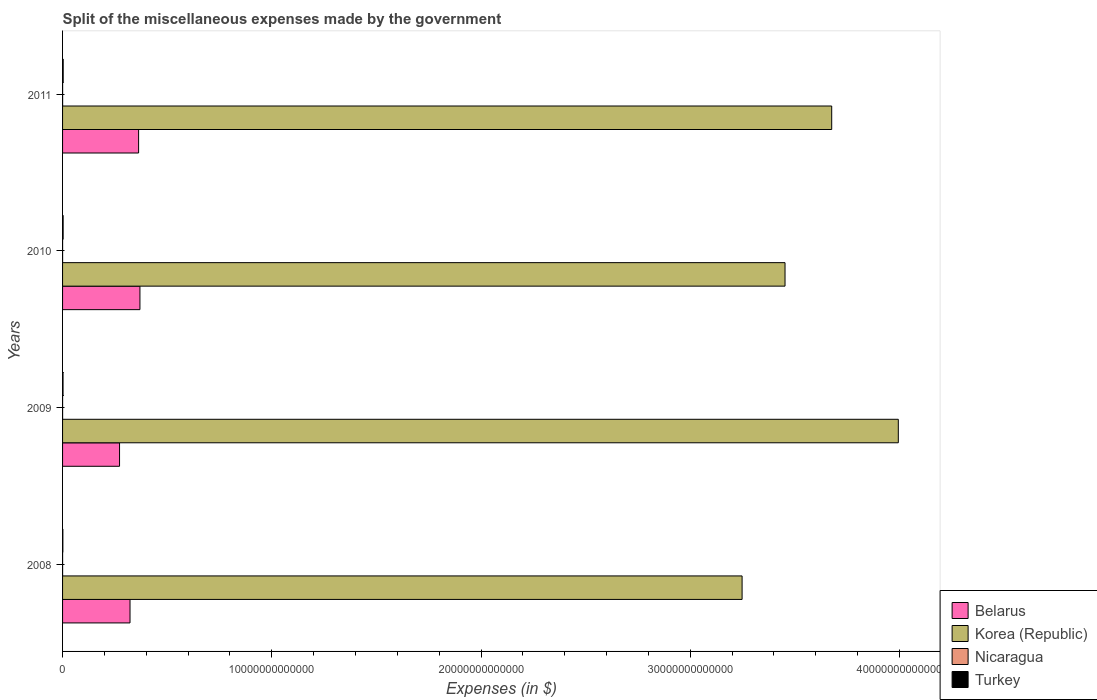How many different coloured bars are there?
Keep it short and to the point. 4. How many groups of bars are there?
Offer a terse response. 4. Are the number of bars per tick equal to the number of legend labels?
Offer a terse response. Yes. How many bars are there on the 2nd tick from the top?
Provide a succinct answer. 4. How many bars are there on the 2nd tick from the bottom?
Give a very brief answer. 4. What is the label of the 3rd group of bars from the top?
Offer a very short reply. 2009. What is the miscellaneous expenses made by the government in Belarus in 2008?
Provide a succinct answer. 3.22e+12. Across all years, what is the maximum miscellaneous expenses made by the government in Korea (Republic)?
Keep it short and to the point. 3.99e+13. Across all years, what is the minimum miscellaneous expenses made by the government in Turkey?
Keep it short and to the point. 1.38e+1. What is the total miscellaneous expenses made by the government in Nicaragua in the graph?
Your answer should be compact. 6.28e+09. What is the difference between the miscellaneous expenses made by the government in Belarus in 2009 and that in 2010?
Ensure brevity in your answer.  -9.74e+11. What is the difference between the miscellaneous expenses made by the government in Turkey in 2009 and the miscellaneous expenses made by the government in Belarus in 2011?
Give a very brief answer. -3.61e+12. What is the average miscellaneous expenses made by the government in Korea (Republic) per year?
Provide a short and direct response. 3.59e+13. In the year 2010, what is the difference between the miscellaneous expenses made by the government in Korea (Republic) and miscellaneous expenses made by the government in Belarus?
Offer a very short reply. 3.08e+13. In how many years, is the miscellaneous expenses made by the government in Turkey greater than 30000000000000 $?
Give a very brief answer. 0. What is the ratio of the miscellaneous expenses made by the government in Korea (Republic) in 2009 to that in 2010?
Ensure brevity in your answer.  1.16. Is the miscellaneous expenses made by the government in Turkey in 2010 less than that in 2011?
Offer a terse response. Yes. Is the difference between the miscellaneous expenses made by the government in Korea (Republic) in 2010 and 2011 greater than the difference between the miscellaneous expenses made by the government in Belarus in 2010 and 2011?
Your response must be concise. No. What is the difference between the highest and the second highest miscellaneous expenses made by the government in Nicaragua?
Make the answer very short. 1.44e+08. What is the difference between the highest and the lowest miscellaneous expenses made by the government in Nicaragua?
Give a very brief answer. 3.96e+08. Is the sum of the miscellaneous expenses made by the government in Turkey in 2008 and 2010 greater than the maximum miscellaneous expenses made by the government in Korea (Republic) across all years?
Your answer should be compact. No. Is it the case that in every year, the sum of the miscellaneous expenses made by the government in Nicaragua and miscellaneous expenses made by the government in Belarus is greater than the sum of miscellaneous expenses made by the government in Turkey and miscellaneous expenses made by the government in Korea (Republic)?
Offer a terse response. No. What does the 2nd bar from the top in 2008 represents?
Your answer should be very brief. Nicaragua. What does the 2nd bar from the bottom in 2009 represents?
Make the answer very short. Korea (Republic). What is the difference between two consecutive major ticks on the X-axis?
Ensure brevity in your answer.  1.00e+13. Does the graph contain any zero values?
Ensure brevity in your answer.  No. How are the legend labels stacked?
Your response must be concise. Vertical. What is the title of the graph?
Offer a terse response. Split of the miscellaneous expenses made by the government. Does "Cyprus" appear as one of the legend labels in the graph?
Keep it short and to the point. No. What is the label or title of the X-axis?
Provide a succinct answer. Expenses (in $). What is the Expenses (in $) in Belarus in 2008?
Make the answer very short. 3.22e+12. What is the Expenses (in $) in Korea (Republic) in 2008?
Offer a terse response. 3.25e+13. What is the Expenses (in $) of Nicaragua in 2008?
Your response must be concise. 1.65e+09. What is the Expenses (in $) of Turkey in 2008?
Your response must be concise. 1.38e+1. What is the Expenses (in $) in Belarus in 2009?
Keep it short and to the point. 2.72e+12. What is the Expenses (in $) in Korea (Republic) in 2009?
Offer a terse response. 3.99e+13. What is the Expenses (in $) in Nicaragua in 2009?
Give a very brief answer. 1.42e+09. What is the Expenses (in $) of Turkey in 2009?
Keep it short and to the point. 2.21e+1. What is the Expenses (in $) of Belarus in 2010?
Offer a very short reply. 3.70e+12. What is the Expenses (in $) in Korea (Republic) in 2010?
Offer a terse response. 3.45e+13. What is the Expenses (in $) in Nicaragua in 2010?
Your response must be concise. 1.40e+09. What is the Expenses (in $) in Turkey in 2010?
Provide a succinct answer. 2.64e+1. What is the Expenses (in $) in Belarus in 2011?
Your answer should be very brief. 3.63e+12. What is the Expenses (in $) in Korea (Republic) in 2011?
Your answer should be compact. 3.68e+13. What is the Expenses (in $) of Nicaragua in 2011?
Offer a very short reply. 1.80e+09. What is the Expenses (in $) in Turkey in 2011?
Your answer should be compact. 2.91e+1. Across all years, what is the maximum Expenses (in $) in Belarus?
Provide a succinct answer. 3.70e+12. Across all years, what is the maximum Expenses (in $) in Korea (Republic)?
Provide a short and direct response. 3.99e+13. Across all years, what is the maximum Expenses (in $) of Nicaragua?
Give a very brief answer. 1.80e+09. Across all years, what is the maximum Expenses (in $) of Turkey?
Give a very brief answer. 2.91e+1. Across all years, what is the minimum Expenses (in $) of Belarus?
Make the answer very short. 2.72e+12. Across all years, what is the minimum Expenses (in $) in Korea (Republic)?
Your answer should be compact. 3.25e+13. Across all years, what is the minimum Expenses (in $) of Nicaragua?
Offer a very short reply. 1.40e+09. Across all years, what is the minimum Expenses (in $) in Turkey?
Ensure brevity in your answer.  1.38e+1. What is the total Expenses (in $) in Belarus in the graph?
Ensure brevity in your answer.  1.33e+13. What is the total Expenses (in $) of Korea (Republic) in the graph?
Keep it short and to the point. 1.44e+14. What is the total Expenses (in $) in Nicaragua in the graph?
Provide a succinct answer. 6.28e+09. What is the total Expenses (in $) of Turkey in the graph?
Your response must be concise. 9.14e+1. What is the difference between the Expenses (in $) of Belarus in 2008 and that in 2009?
Your answer should be compact. 5.00e+11. What is the difference between the Expenses (in $) of Korea (Republic) in 2008 and that in 2009?
Offer a terse response. -7.47e+12. What is the difference between the Expenses (in $) in Nicaragua in 2008 and that in 2009?
Provide a short and direct response. 2.35e+08. What is the difference between the Expenses (in $) in Turkey in 2008 and that in 2009?
Offer a very short reply. -8.25e+09. What is the difference between the Expenses (in $) in Belarus in 2008 and that in 2010?
Your answer should be compact. -4.74e+11. What is the difference between the Expenses (in $) of Korea (Republic) in 2008 and that in 2010?
Provide a succinct answer. -2.05e+12. What is the difference between the Expenses (in $) of Nicaragua in 2008 and that in 2010?
Ensure brevity in your answer.  2.52e+08. What is the difference between the Expenses (in $) of Turkey in 2008 and that in 2010?
Offer a very short reply. -1.26e+1. What is the difference between the Expenses (in $) of Belarus in 2008 and that in 2011?
Your answer should be compact. -4.11e+11. What is the difference between the Expenses (in $) of Korea (Republic) in 2008 and that in 2011?
Your response must be concise. -4.28e+12. What is the difference between the Expenses (in $) of Nicaragua in 2008 and that in 2011?
Your answer should be very brief. -1.44e+08. What is the difference between the Expenses (in $) of Turkey in 2008 and that in 2011?
Your answer should be very brief. -1.53e+1. What is the difference between the Expenses (in $) in Belarus in 2009 and that in 2010?
Make the answer very short. -9.74e+11. What is the difference between the Expenses (in $) in Korea (Republic) in 2009 and that in 2010?
Your response must be concise. 5.41e+12. What is the difference between the Expenses (in $) of Nicaragua in 2009 and that in 2010?
Provide a succinct answer. 1.63e+07. What is the difference between the Expenses (in $) of Turkey in 2009 and that in 2010?
Offer a very short reply. -4.34e+09. What is the difference between the Expenses (in $) of Belarus in 2009 and that in 2011?
Your answer should be very brief. -9.11e+11. What is the difference between the Expenses (in $) in Korea (Republic) in 2009 and that in 2011?
Your answer should be very brief. 3.18e+12. What is the difference between the Expenses (in $) in Nicaragua in 2009 and that in 2011?
Offer a very short reply. -3.80e+08. What is the difference between the Expenses (in $) in Turkey in 2009 and that in 2011?
Keep it short and to the point. -7.08e+09. What is the difference between the Expenses (in $) of Belarus in 2010 and that in 2011?
Keep it short and to the point. 6.31e+1. What is the difference between the Expenses (in $) in Korea (Republic) in 2010 and that in 2011?
Offer a very short reply. -2.23e+12. What is the difference between the Expenses (in $) in Nicaragua in 2010 and that in 2011?
Offer a terse response. -3.96e+08. What is the difference between the Expenses (in $) of Turkey in 2010 and that in 2011?
Give a very brief answer. -2.75e+09. What is the difference between the Expenses (in $) of Belarus in 2008 and the Expenses (in $) of Korea (Republic) in 2009?
Provide a succinct answer. -3.67e+13. What is the difference between the Expenses (in $) of Belarus in 2008 and the Expenses (in $) of Nicaragua in 2009?
Offer a very short reply. 3.22e+12. What is the difference between the Expenses (in $) in Belarus in 2008 and the Expenses (in $) in Turkey in 2009?
Offer a very short reply. 3.20e+12. What is the difference between the Expenses (in $) of Korea (Republic) in 2008 and the Expenses (in $) of Nicaragua in 2009?
Provide a succinct answer. 3.25e+13. What is the difference between the Expenses (in $) in Korea (Republic) in 2008 and the Expenses (in $) in Turkey in 2009?
Your answer should be very brief. 3.25e+13. What is the difference between the Expenses (in $) in Nicaragua in 2008 and the Expenses (in $) in Turkey in 2009?
Your answer should be very brief. -2.04e+1. What is the difference between the Expenses (in $) of Belarus in 2008 and the Expenses (in $) of Korea (Republic) in 2010?
Ensure brevity in your answer.  -3.13e+13. What is the difference between the Expenses (in $) in Belarus in 2008 and the Expenses (in $) in Nicaragua in 2010?
Provide a short and direct response. 3.22e+12. What is the difference between the Expenses (in $) in Belarus in 2008 and the Expenses (in $) in Turkey in 2010?
Your answer should be very brief. 3.20e+12. What is the difference between the Expenses (in $) of Korea (Republic) in 2008 and the Expenses (in $) of Nicaragua in 2010?
Your answer should be very brief. 3.25e+13. What is the difference between the Expenses (in $) in Korea (Republic) in 2008 and the Expenses (in $) in Turkey in 2010?
Provide a short and direct response. 3.25e+13. What is the difference between the Expenses (in $) in Nicaragua in 2008 and the Expenses (in $) in Turkey in 2010?
Offer a terse response. -2.47e+1. What is the difference between the Expenses (in $) in Belarus in 2008 and the Expenses (in $) in Korea (Republic) in 2011?
Keep it short and to the point. -3.35e+13. What is the difference between the Expenses (in $) of Belarus in 2008 and the Expenses (in $) of Nicaragua in 2011?
Ensure brevity in your answer.  3.22e+12. What is the difference between the Expenses (in $) of Belarus in 2008 and the Expenses (in $) of Turkey in 2011?
Offer a terse response. 3.19e+12. What is the difference between the Expenses (in $) in Korea (Republic) in 2008 and the Expenses (in $) in Nicaragua in 2011?
Provide a short and direct response. 3.25e+13. What is the difference between the Expenses (in $) of Korea (Republic) in 2008 and the Expenses (in $) of Turkey in 2011?
Make the answer very short. 3.25e+13. What is the difference between the Expenses (in $) in Nicaragua in 2008 and the Expenses (in $) in Turkey in 2011?
Ensure brevity in your answer.  -2.75e+1. What is the difference between the Expenses (in $) of Belarus in 2009 and the Expenses (in $) of Korea (Republic) in 2010?
Keep it short and to the point. -3.18e+13. What is the difference between the Expenses (in $) of Belarus in 2009 and the Expenses (in $) of Nicaragua in 2010?
Provide a short and direct response. 2.72e+12. What is the difference between the Expenses (in $) in Belarus in 2009 and the Expenses (in $) in Turkey in 2010?
Make the answer very short. 2.70e+12. What is the difference between the Expenses (in $) of Korea (Republic) in 2009 and the Expenses (in $) of Nicaragua in 2010?
Make the answer very short. 3.99e+13. What is the difference between the Expenses (in $) in Korea (Republic) in 2009 and the Expenses (in $) in Turkey in 2010?
Provide a short and direct response. 3.99e+13. What is the difference between the Expenses (in $) in Nicaragua in 2009 and the Expenses (in $) in Turkey in 2010?
Offer a terse response. -2.50e+1. What is the difference between the Expenses (in $) of Belarus in 2009 and the Expenses (in $) of Korea (Republic) in 2011?
Keep it short and to the point. -3.40e+13. What is the difference between the Expenses (in $) of Belarus in 2009 and the Expenses (in $) of Nicaragua in 2011?
Your answer should be compact. 2.72e+12. What is the difference between the Expenses (in $) in Belarus in 2009 and the Expenses (in $) in Turkey in 2011?
Keep it short and to the point. 2.69e+12. What is the difference between the Expenses (in $) in Korea (Republic) in 2009 and the Expenses (in $) in Nicaragua in 2011?
Your answer should be compact. 3.99e+13. What is the difference between the Expenses (in $) in Korea (Republic) in 2009 and the Expenses (in $) in Turkey in 2011?
Ensure brevity in your answer.  3.99e+13. What is the difference between the Expenses (in $) of Nicaragua in 2009 and the Expenses (in $) of Turkey in 2011?
Ensure brevity in your answer.  -2.77e+1. What is the difference between the Expenses (in $) of Belarus in 2010 and the Expenses (in $) of Korea (Republic) in 2011?
Provide a succinct answer. -3.31e+13. What is the difference between the Expenses (in $) of Belarus in 2010 and the Expenses (in $) of Nicaragua in 2011?
Keep it short and to the point. 3.70e+12. What is the difference between the Expenses (in $) of Belarus in 2010 and the Expenses (in $) of Turkey in 2011?
Offer a terse response. 3.67e+12. What is the difference between the Expenses (in $) of Korea (Republic) in 2010 and the Expenses (in $) of Nicaragua in 2011?
Offer a terse response. 3.45e+13. What is the difference between the Expenses (in $) of Korea (Republic) in 2010 and the Expenses (in $) of Turkey in 2011?
Offer a very short reply. 3.45e+13. What is the difference between the Expenses (in $) in Nicaragua in 2010 and the Expenses (in $) in Turkey in 2011?
Provide a short and direct response. -2.77e+1. What is the average Expenses (in $) in Belarus per year?
Your answer should be very brief. 3.32e+12. What is the average Expenses (in $) in Korea (Republic) per year?
Your response must be concise. 3.59e+13. What is the average Expenses (in $) in Nicaragua per year?
Your answer should be compact. 1.57e+09. What is the average Expenses (in $) in Turkey per year?
Offer a terse response. 2.29e+1. In the year 2008, what is the difference between the Expenses (in $) in Belarus and Expenses (in $) in Korea (Republic)?
Make the answer very short. -2.93e+13. In the year 2008, what is the difference between the Expenses (in $) of Belarus and Expenses (in $) of Nicaragua?
Give a very brief answer. 3.22e+12. In the year 2008, what is the difference between the Expenses (in $) in Belarus and Expenses (in $) in Turkey?
Give a very brief answer. 3.21e+12. In the year 2008, what is the difference between the Expenses (in $) of Korea (Republic) and Expenses (in $) of Nicaragua?
Provide a succinct answer. 3.25e+13. In the year 2008, what is the difference between the Expenses (in $) in Korea (Republic) and Expenses (in $) in Turkey?
Your answer should be very brief. 3.25e+13. In the year 2008, what is the difference between the Expenses (in $) in Nicaragua and Expenses (in $) in Turkey?
Provide a succinct answer. -1.22e+1. In the year 2009, what is the difference between the Expenses (in $) of Belarus and Expenses (in $) of Korea (Republic)?
Give a very brief answer. -3.72e+13. In the year 2009, what is the difference between the Expenses (in $) of Belarus and Expenses (in $) of Nicaragua?
Make the answer very short. 2.72e+12. In the year 2009, what is the difference between the Expenses (in $) of Belarus and Expenses (in $) of Turkey?
Offer a terse response. 2.70e+12. In the year 2009, what is the difference between the Expenses (in $) in Korea (Republic) and Expenses (in $) in Nicaragua?
Offer a very short reply. 3.99e+13. In the year 2009, what is the difference between the Expenses (in $) of Korea (Republic) and Expenses (in $) of Turkey?
Ensure brevity in your answer.  3.99e+13. In the year 2009, what is the difference between the Expenses (in $) in Nicaragua and Expenses (in $) in Turkey?
Provide a succinct answer. -2.06e+1. In the year 2010, what is the difference between the Expenses (in $) in Belarus and Expenses (in $) in Korea (Republic)?
Provide a succinct answer. -3.08e+13. In the year 2010, what is the difference between the Expenses (in $) of Belarus and Expenses (in $) of Nicaragua?
Your answer should be very brief. 3.70e+12. In the year 2010, what is the difference between the Expenses (in $) of Belarus and Expenses (in $) of Turkey?
Ensure brevity in your answer.  3.67e+12. In the year 2010, what is the difference between the Expenses (in $) in Korea (Republic) and Expenses (in $) in Nicaragua?
Your response must be concise. 3.45e+13. In the year 2010, what is the difference between the Expenses (in $) in Korea (Republic) and Expenses (in $) in Turkey?
Provide a succinct answer. 3.45e+13. In the year 2010, what is the difference between the Expenses (in $) of Nicaragua and Expenses (in $) of Turkey?
Keep it short and to the point. -2.50e+1. In the year 2011, what is the difference between the Expenses (in $) in Belarus and Expenses (in $) in Korea (Republic)?
Make the answer very short. -3.31e+13. In the year 2011, what is the difference between the Expenses (in $) in Belarus and Expenses (in $) in Nicaragua?
Your answer should be compact. 3.63e+12. In the year 2011, what is the difference between the Expenses (in $) in Belarus and Expenses (in $) in Turkey?
Your answer should be compact. 3.61e+12. In the year 2011, what is the difference between the Expenses (in $) of Korea (Republic) and Expenses (in $) of Nicaragua?
Provide a succinct answer. 3.68e+13. In the year 2011, what is the difference between the Expenses (in $) in Korea (Republic) and Expenses (in $) in Turkey?
Offer a very short reply. 3.67e+13. In the year 2011, what is the difference between the Expenses (in $) of Nicaragua and Expenses (in $) of Turkey?
Provide a short and direct response. -2.73e+1. What is the ratio of the Expenses (in $) of Belarus in 2008 to that in 2009?
Your answer should be very brief. 1.18. What is the ratio of the Expenses (in $) in Korea (Republic) in 2008 to that in 2009?
Offer a terse response. 0.81. What is the ratio of the Expenses (in $) of Nicaragua in 2008 to that in 2009?
Give a very brief answer. 1.17. What is the ratio of the Expenses (in $) of Turkey in 2008 to that in 2009?
Your answer should be very brief. 0.63. What is the ratio of the Expenses (in $) in Belarus in 2008 to that in 2010?
Ensure brevity in your answer.  0.87. What is the ratio of the Expenses (in $) of Korea (Republic) in 2008 to that in 2010?
Your answer should be compact. 0.94. What is the ratio of the Expenses (in $) of Nicaragua in 2008 to that in 2010?
Your response must be concise. 1.18. What is the ratio of the Expenses (in $) of Turkey in 2008 to that in 2010?
Your answer should be very brief. 0.52. What is the ratio of the Expenses (in $) of Belarus in 2008 to that in 2011?
Keep it short and to the point. 0.89. What is the ratio of the Expenses (in $) in Korea (Republic) in 2008 to that in 2011?
Offer a terse response. 0.88. What is the ratio of the Expenses (in $) in Nicaragua in 2008 to that in 2011?
Provide a succinct answer. 0.92. What is the ratio of the Expenses (in $) of Turkey in 2008 to that in 2011?
Provide a succinct answer. 0.47. What is the ratio of the Expenses (in $) in Belarus in 2009 to that in 2010?
Provide a succinct answer. 0.74. What is the ratio of the Expenses (in $) in Korea (Republic) in 2009 to that in 2010?
Provide a short and direct response. 1.16. What is the ratio of the Expenses (in $) in Nicaragua in 2009 to that in 2010?
Offer a terse response. 1.01. What is the ratio of the Expenses (in $) in Turkey in 2009 to that in 2010?
Your answer should be compact. 0.84. What is the ratio of the Expenses (in $) in Belarus in 2009 to that in 2011?
Provide a short and direct response. 0.75. What is the ratio of the Expenses (in $) in Korea (Republic) in 2009 to that in 2011?
Give a very brief answer. 1.09. What is the ratio of the Expenses (in $) in Nicaragua in 2009 to that in 2011?
Give a very brief answer. 0.79. What is the ratio of the Expenses (in $) in Turkey in 2009 to that in 2011?
Ensure brevity in your answer.  0.76. What is the ratio of the Expenses (in $) in Belarus in 2010 to that in 2011?
Make the answer very short. 1.02. What is the ratio of the Expenses (in $) of Korea (Republic) in 2010 to that in 2011?
Your response must be concise. 0.94. What is the ratio of the Expenses (in $) in Nicaragua in 2010 to that in 2011?
Your answer should be very brief. 0.78. What is the ratio of the Expenses (in $) in Turkey in 2010 to that in 2011?
Your answer should be very brief. 0.91. What is the difference between the highest and the second highest Expenses (in $) of Belarus?
Give a very brief answer. 6.31e+1. What is the difference between the highest and the second highest Expenses (in $) in Korea (Republic)?
Your answer should be very brief. 3.18e+12. What is the difference between the highest and the second highest Expenses (in $) of Nicaragua?
Make the answer very short. 1.44e+08. What is the difference between the highest and the second highest Expenses (in $) in Turkey?
Make the answer very short. 2.75e+09. What is the difference between the highest and the lowest Expenses (in $) of Belarus?
Ensure brevity in your answer.  9.74e+11. What is the difference between the highest and the lowest Expenses (in $) in Korea (Republic)?
Your answer should be very brief. 7.47e+12. What is the difference between the highest and the lowest Expenses (in $) of Nicaragua?
Your response must be concise. 3.96e+08. What is the difference between the highest and the lowest Expenses (in $) in Turkey?
Provide a succinct answer. 1.53e+1. 